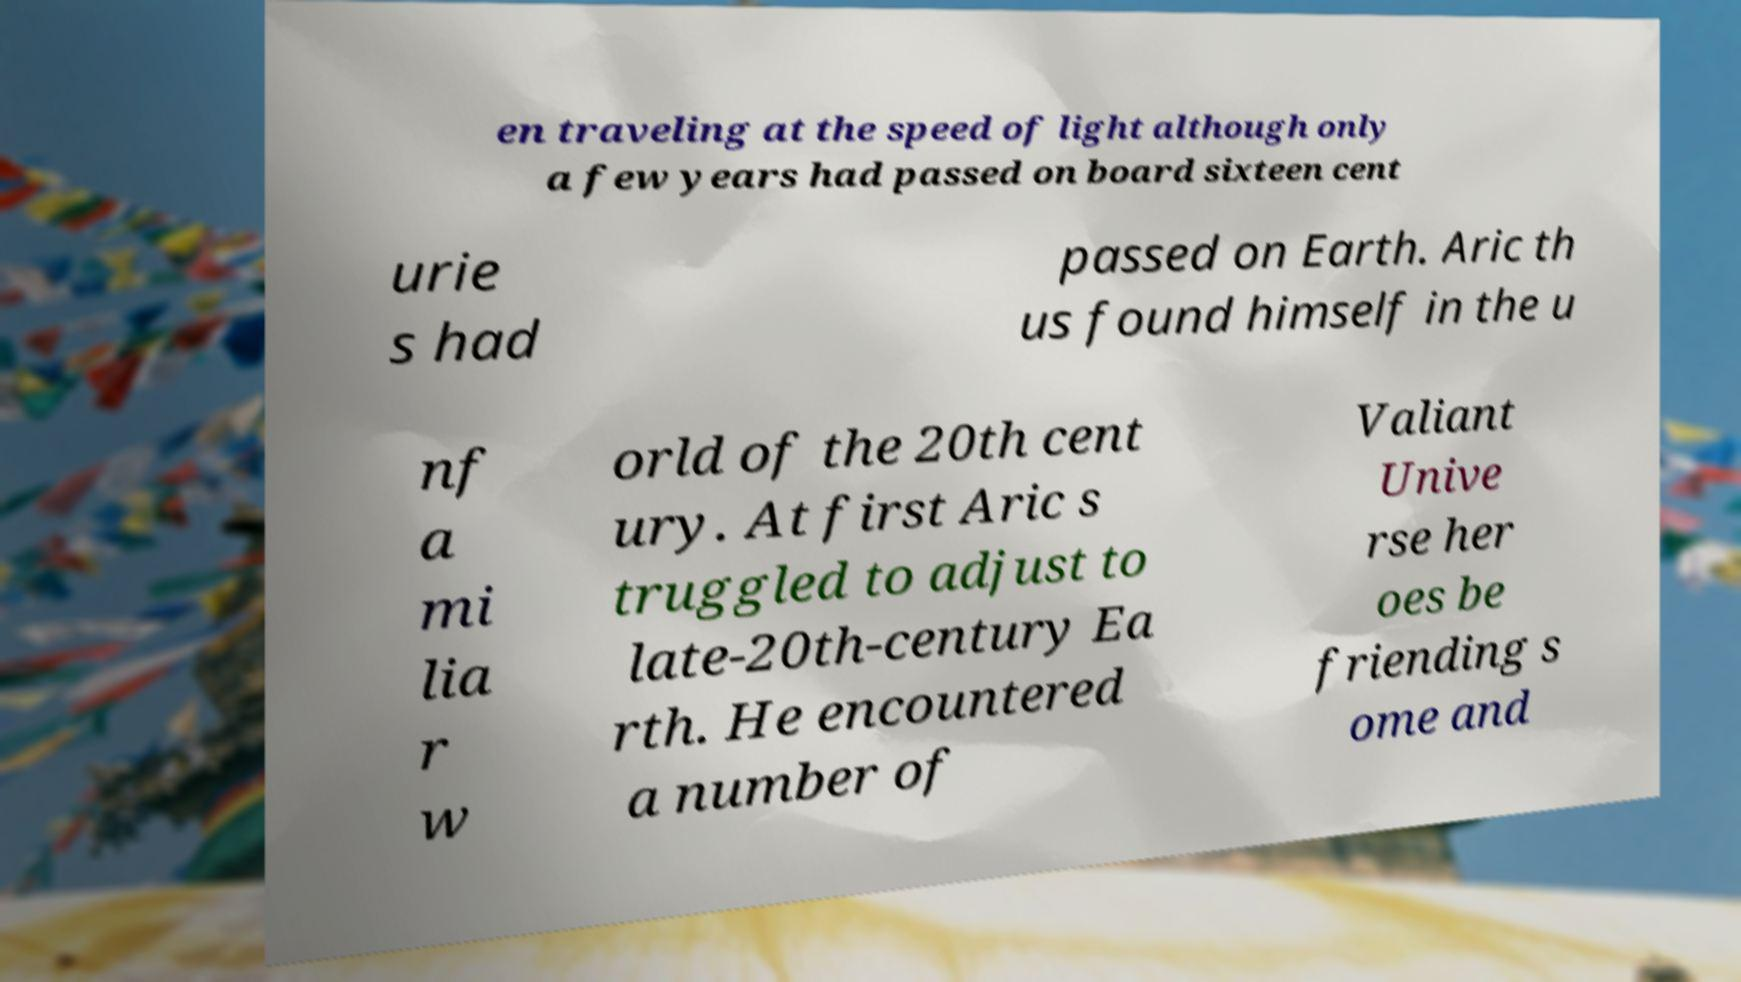What messages or text are displayed in this image? I need them in a readable, typed format. en traveling at the speed of light although only a few years had passed on board sixteen cent urie s had passed on Earth. Aric th us found himself in the u nf a mi lia r w orld of the 20th cent ury. At first Aric s truggled to adjust to late-20th-century Ea rth. He encountered a number of Valiant Unive rse her oes be friending s ome and 